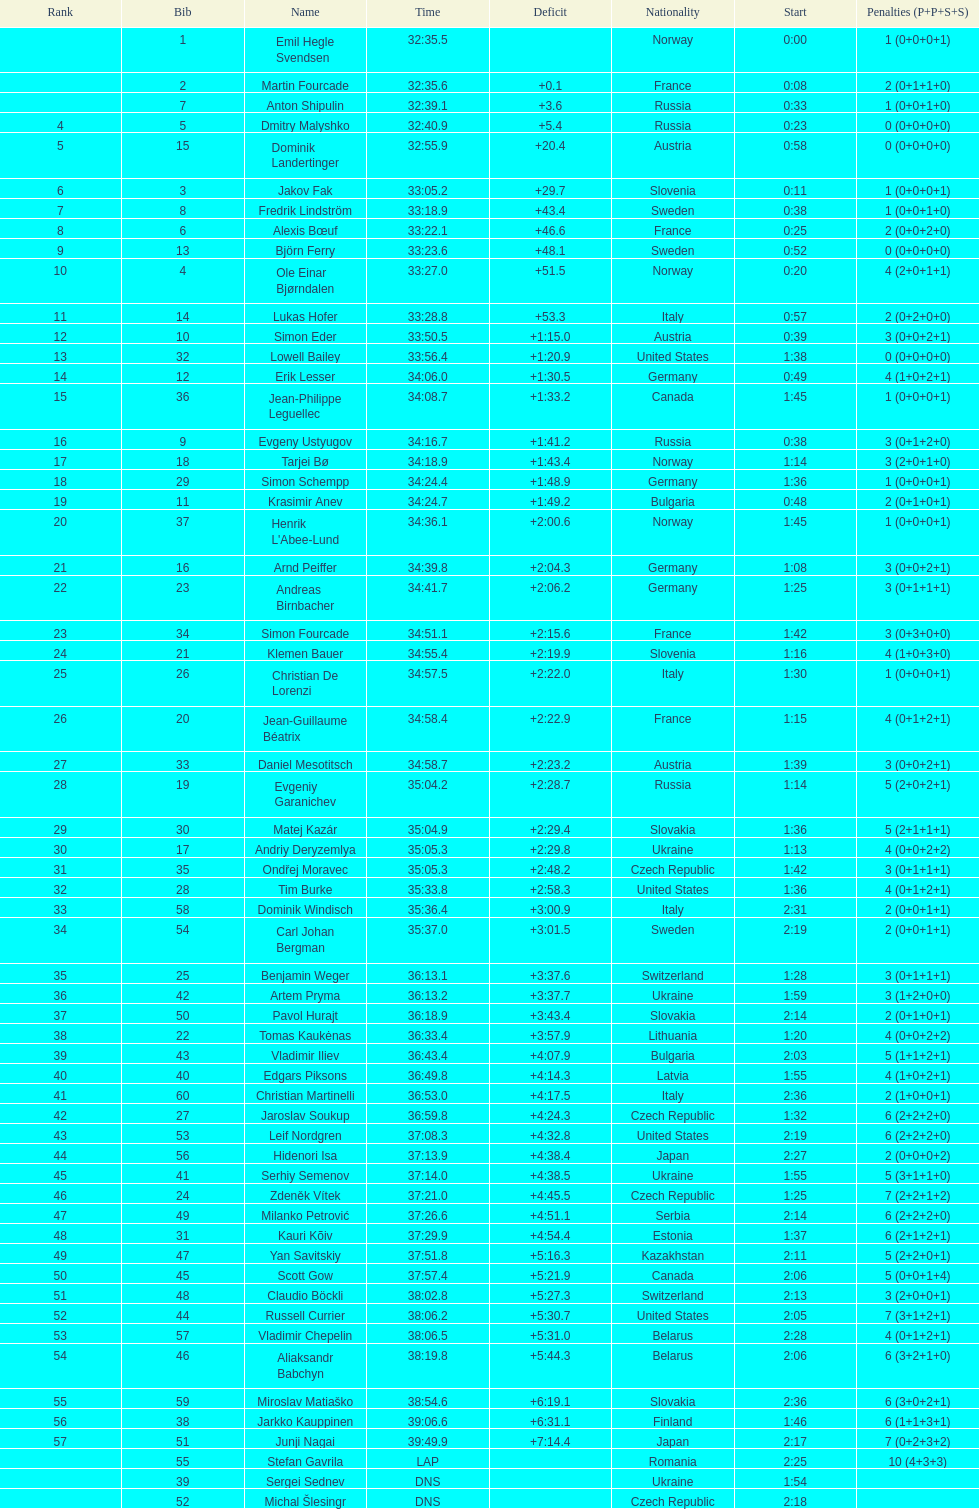What is the total number of participants between norway and france? 7. 